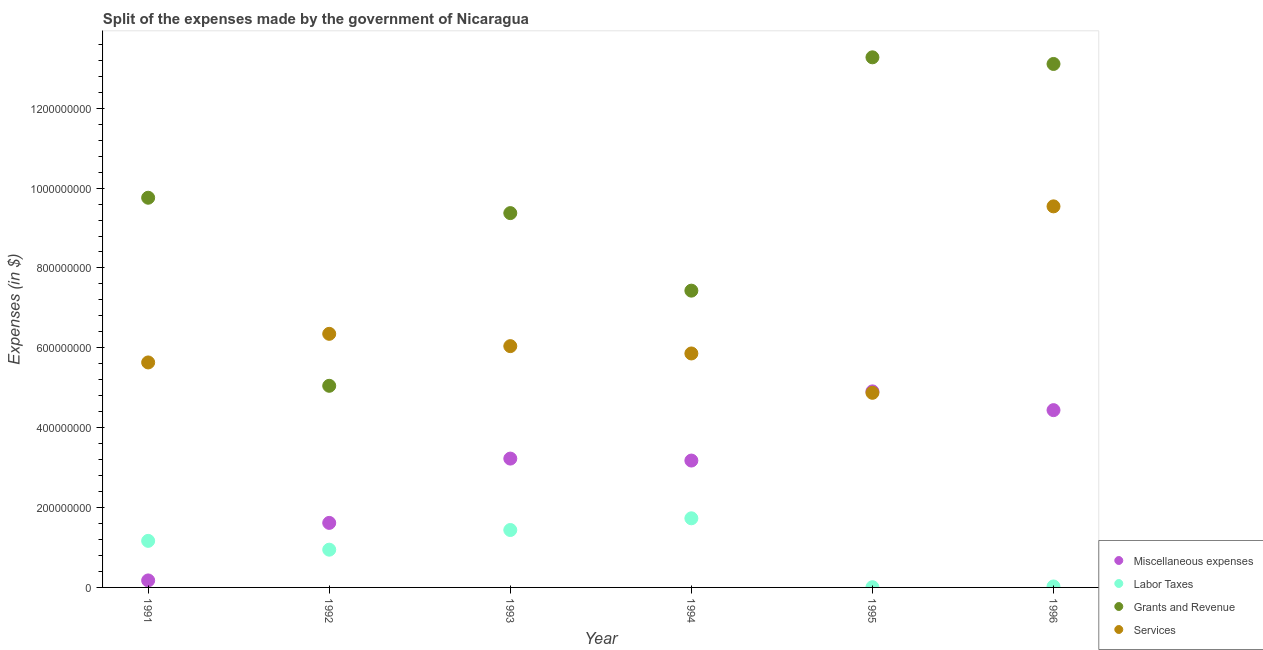How many different coloured dotlines are there?
Ensure brevity in your answer.  4. Is the number of dotlines equal to the number of legend labels?
Offer a very short reply. Yes. What is the amount spent on miscellaneous expenses in 1995?
Your answer should be very brief. 4.91e+08. Across all years, what is the maximum amount spent on grants and revenue?
Offer a very short reply. 1.33e+09. Across all years, what is the minimum amount spent on services?
Provide a succinct answer. 4.87e+08. What is the total amount spent on grants and revenue in the graph?
Offer a terse response. 5.80e+09. What is the difference between the amount spent on services in 1991 and that in 1994?
Give a very brief answer. -2.25e+07. What is the difference between the amount spent on labor taxes in 1993 and the amount spent on grants and revenue in 1996?
Give a very brief answer. -1.17e+09. What is the average amount spent on services per year?
Offer a terse response. 6.38e+08. In the year 1996, what is the difference between the amount spent on miscellaneous expenses and amount spent on labor taxes?
Keep it short and to the point. 4.42e+08. In how many years, is the amount spent on labor taxes greater than 800000000 $?
Your answer should be very brief. 0. What is the ratio of the amount spent on miscellaneous expenses in 1991 to that in 1994?
Your answer should be compact. 0.06. What is the difference between the highest and the second highest amount spent on services?
Ensure brevity in your answer.  3.19e+08. What is the difference between the highest and the lowest amount spent on services?
Your answer should be very brief. 4.67e+08. In how many years, is the amount spent on grants and revenue greater than the average amount spent on grants and revenue taken over all years?
Ensure brevity in your answer.  3. Is it the case that in every year, the sum of the amount spent on grants and revenue and amount spent on miscellaneous expenses is greater than the sum of amount spent on labor taxes and amount spent on services?
Make the answer very short. No. Is it the case that in every year, the sum of the amount spent on miscellaneous expenses and amount spent on labor taxes is greater than the amount spent on grants and revenue?
Keep it short and to the point. No. Does the amount spent on services monotonically increase over the years?
Offer a terse response. No. How many years are there in the graph?
Make the answer very short. 6. What is the difference between two consecutive major ticks on the Y-axis?
Provide a short and direct response. 2.00e+08. Are the values on the major ticks of Y-axis written in scientific E-notation?
Offer a very short reply. No. Does the graph contain any zero values?
Provide a short and direct response. No. Does the graph contain grids?
Offer a terse response. No. How many legend labels are there?
Keep it short and to the point. 4. How are the legend labels stacked?
Ensure brevity in your answer.  Vertical. What is the title of the graph?
Provide a short and direct response. Split of the expenses made by the government of Nicaragua. What is the label or title of the X-axis?
Provide a short and direct response. Year. What is the label or title of the Y-axis?
Offer a terse response. Expenses (in $). What is the Expenses (in $) in Miscellaneous expenses in 1991?
Ensure brevity in your answer.  1.75e+07. What is the Expenses (in $) of Labor Taxes in 1991?
Your response must be concise. 1.17e+08. What is the Expenses (in $) in Grants and Revenue in 1991?
Keep it short and to the point. 9.76e+08. What is the Expenses (in $) in Services in 1991?
Offer a terse response. 5.63e+08. What is the Expenses (in $) of Miscellaneous expenses in 1992?
Provide a short and direct response. 1.62e+08. What is the Expenses (in $) of Labor Taxes in 1992?
Give a very brief answer. 9.45e+07. What is the Expenses (in $) of Grants and Revenue in 1992?
Your answer should be very brief. 5.05e+08. What is the Expenses (in $) in Services in 1992?
Your response must be concise. 6.35e+08. What is the Expenses (in $) of Miscellaneous expenses in 1993?
Provide a short and direct response. 3.23e+08. What is the Expenses (in $) of Labor Taxes in 1993?
Ensure brevity in your answer.  1.44e+08. What is the Expenses (in $) in Grants and Revenue in 1993?
Offer a terse response. 9.37e+08. What is the Expenses (in $) of Services in 1993?
Ensure brevity in your answer.  6.04e+08. What is the Expenses (in $) in Miscellaneous expenses in 1994?
Make the answer very short. 3.18e+08. What is the Expenses (in $) of Labor Taxes in 1994?
Your answer should be compact. 1.73e+08. What is the Expenses (in $) in Grants and Revenue in 1994?
Provide a succinct answer. 7.43e+08. What is the Expenses (in $) in Services in 1994?
Give a very brief answer. 5.86e+08. What is the Expenses (in $) of Miscellaneous expenses in 1995?
Keep it short and to the point. 4.91e+08. What is the Expenses (in $) of Labor Taxes in 1995?
Offer a very short reply. 5.40e+05. What is the Expenses (in $) of Grants and Revenue in 1995?
Offer a terse response. 1.33e+09. What is the Expenses (in $) of Services in 1995?
Keep it short and to the point. 4.87e+08. What is the Expenses (in $) in Miscellaneous expenses in 1996?
Your response must be concise. 4.44e+08. What is the Expenses (in $) in Labor Taxes in 1996?
Provide a short and direct response. 2.40e+06. What is the Expenses (in $) of Grants and Revenue in 1996?
Offer a terse response. 1.31e+09. What is the Expenses (in $) in Services in 1996?
Your answer should be compact. 9.54e+08. Across all years, what is the maximum Expenses (in $) of Miscellaneous expenses?
Give a very brief answer. 4.91e+08. Across all years, what is the maximum Expenses (in $) of Labor Taxes?
Provide a short and direct response. 1.73e+08. Across all years, what is the maximum Expenses (in $) in Grants and Revenue?
Give a very brief answer. 1.33e+09. Across all years, what is the maximum Expenses (in $) in Services?
Ensure brevity in your answer.  9.54e+08. Across all years, what is the minimum Expenses (in $) in Miscellaneous expenses?
Ensure brevity in your answer.  1.75e+07. Across all years, what is the minimum Expenses (in $) in Labor Taxes?
Provide a succinct answer. 5.40e+05. Across all years, what is the minimum Expenses (in $) of Grants and Revenue?
Your answer should be very brief. 5.05e+08. Across all years, what is the minimum Expenses (in $) of Services?
Your answer should be very brief. 4.87e+08. What is the total Expenses (in $) in Miscellaneous expenses in the graph?
Ensure brevity in your answer.  1.75e+09. What is the total Expenses (in $) in Labor Taxes in the graph?
Offer a terse response. 5.31e+08. What is the total Expenses (in $) in Grants and Revenue in the graph?
Give a very brief answer. 5.80e+09. What is the total Expenses (in $) of Services in the graph?
Ensure brevity in your answer.  3.83e+09. What is the difference between the Expenses (in $) in Miscellaneous expenses in 1991 and that in 1992?
Provide a short and direct response. -1.44e+08. What is the difference between the Expenses (in $) of Labor Taxes in 1991 and that in 1992?
Keep it short and to the point. 2.20e+07. What is the difference between the Expenses (in $) in Grants and Revenue in 1991 and that in 1992?
Offer a terse response. 4.71e+08. What is the difference between the Expenses (in $) in Services in 1991 and that in 1992?
Offer a very short reply. -7.16e+07. What is the difference between the Expenses (in $) of Miscellaneous expenses in 1991 and that in 1993?
Offer a terse response. -3.05e+08. What is the difference between the Expenses (in $) in Labor Taxes in 1991 and that in 1993?
Your answer should be very brief. -2.72e+07. What is the difference between the Expenses (in $) in Grants and Revenue in 1991 and that in 1993?
Your response must be concise. 3.85e+07. What is the difference between the Expenses (in $) of Services in 1991 and that in 1993?
Your response must be concise. -4.08e+07. What is the difference between the Expenses (in $) in Miscellaneous expenses in 1991 and that in 1994?
Keep it short and to the point. -3.00e+08. What is the difference between the Expenses (in $) in Labor Taxes in 1991 and that in 1994?
Your answer should be compact. -5.65e+07. What is the difference between the Expenses (in $) in Grants and Revenue in 1991 and that in 1994?
Make the answer very short. 2.33e+08. What is the difference between the Expenses (in $) of Services in 1991 and that in 1994?
Make the answer very short. -2.25e+07. What is the difference between the Expenses (in $) in Miscellaneous expenses in 1991 and that in 1995?
Keep it short and to the point. -4.73e+08. What is the difference between the Expenses (in $) in Labor Taxes in 1991 and that in 1995?
Make the answer very short. 1.16e+08. What is the difference between the Expenses (in $) in Grants and Revenue in 1991 and that in 1995?
Your answer should be very brief. -3.52e+08. What is the difference between the Expenses (in $) of Services in 1991 and that in 1995?
Offer a terse response. 7.61e+07. What is the difference between the Expenses (in $) in Miscellaneous expenses in 1991 and that in 1996?
Your answer should be compact. -4.26e+08. What is the difference between the Expenses (in $) in Labor Taxes in 1991 and that in 1996?
Offer a very short reply. 1.14e+08. What is the difference between the Expenses (in $) of Grants and Revenue in 1991 and that in 1996?
Provide a succinct answer. -3.35e+08. What is the difference between the Expenses (in $) of Services in 1991 and that in 1996?
Offer a very short reply. -3.91e+08. What is the difference between the Expenses (in $) in Miscellaneous expenses in 1992 and that in 1993?
Offer a very short reply. -1.61e+08. What is the difference between the Expenses (in $) of Labor Taxes in 1992 and that in 1993?
Provide a succinct answer. -4.93e+07. What is the difference between the Expenses (in $) of Grants and Revenue in 1992 and that in 1993?
Ensure brevity in your answer.  -4.32e+08. What is the difference between the Expenses (in $) of Services in 1992 and that in 1993?
Make the answer very short. 3.08e+07. What is the difference between the Expenses (in $) in Miscellaneous expenses in 1992 and that in 1994?
Offer a terse response. -1.56e+08. What is the difference between the Expenses (in $) of Labor Taxes in 1992 and that in 1994?
Your answer should be compact. -7.86e+07. What is the difference between the Expenses (in $) in Grants and Revenue in 1992 and that in 1994?
Your answer should be compact. -2.38e+08. What is the difference between the Expenses (in $) in Services in 1992 and that in 1994?
Your answer should be compact. 4.92e+07. What is the difference between the Expenses (in $) in Miscellaneous expenses in 1992 and that in 1995?
Offer a very short reply. -3.29e+08. What is the difference between the Expenses (in $) in Labor Taxes in 1992 and that in 1995?
Give a very brief answer. 9.40e+07. What is the difference between the Expenses (in $) of Grants and Revenue in 1992 and that in 1995?
Provide a succinct answer. -8.23e+08. What is the difference between the Expenses (in $) in Services in 1992 and that in 1995?
Offer a very short reply. 1.48e+08. What is the difference between the Expenses (in $) in Miscellaneous expenses in 1992 and that in 1996?
Keep it short and to the point. -2.82e+08. What is the difference between the Expenses (in $) in Labor Taxes in 1992 and that in 1996?
Your answer should be very brief. 9.21e+07. What is the difference between the Expenses (in $) in Grants and Revenue in 1992 and that in 1996?
Your response must be concise. -8.06e+08. What is the difference between the Expenses (in $) in Services in 1992 and that in 1996?
Your response must be concise. -3.19e+08. What is the difference between the Expenses (in $) of Miscellaneous expenses in 1993 and that in 1994?
Offer a very short reply. 4.91e+06. What is the difference between the Expenses (in $) in Labor Taxes in 1993 and that in 1994?
Ensure brevity in your answer.  -2.93e+07. What is the difference between the Expenses (in $) of Grants and Revenue in 1993 and that in 1994?
Your answer should be compact. 1.94e+08. What is the difference between the Expenses (in $) in Services in 1993 and that in 1994?
Give a very brief answer. 1.84e+07. What is the difference between the Expenses (in $) of Miscellaneous expenses in 1993 and that in 1995?
Your response must be concise. -1.68e+08. What is the difference between the Expenses (in $) in Labor Taxes in 1993 and that in 1995?
Your answer should be very brief. 1.43e+08. What is the difference between the Expenses (in $) of Grants and Revenue in 1993 and that in 1995?
Your response must be concise. -3.90e+08. What is the difference between the Expenses (in $) of Services in 1993 and that in 1995?
Provide a succinct answer. 1.17e+08. What is the difference between the Expenses (in $) of Miscellaneous expenses in 1993 and that in 1996?
Offer a terse response. -1.21e+08. What is the difference between the Expenses (in $) in Labor Taxes in 1993 and that in 1996?
Ensure brevity in your answer.  1.41e+08. What is the difference between the Expenses (in $) in Grants and Revenue in 1993 and that in 1996?
Keep it short and to the point. -3.74e+08. What is the difference between the Expenses (in $) in Services in 1993 and that in 1996?
Keep it short and to the point. -3.50e+08. What is the difference between the Expenses (in $) in Miscellaneous expenses in 1994 and that in 1995?
Ensure brevity in your answer.  -1.73e+08. What is the difference between the Expenses (in $) of Labor Taxes in 1994 and that in 1995?
Provide a succinct answer. 1.73e+08. What is the difference between the Expenses (in $) of Grants and Revenue in 1994 and that in 1995?
Provide a short and direct response. -5.84e+08. What is the difference between the Expenses (in $) in Services in 1994 and that in 1995?
Make the answer very short. 9.85e+07. What is the difference between the Expenses (in $) in Miscellaneous expenses in 1994 and that in 1996?
Ensure brevity in your answer.  -1.26e+08. What is the difference between the Expenses (in $) in Labor Taxes in 1994 and that in 1996?
Your answer should be compact. 1.71e+08. What is the difference between the Expenses (in $) in Grants and Revenue in 1994 and that in 1996?
Keep it short and to the point. -5.68e+08. What is the difference between the Expenses (in $) in Services in 1994 and that in 1996?
Your answer should be compact. -3.68e+08. What is the difference between the Expenses (in $) in Miscellaneous expenses in 1995 and that in 1996?
Ensure brevity in your answer.  4.70e+07. What is the difference between the Expenses (in $) in Labor Taxes in 1995 and that in 1996?
Provide a succinct answer. -1.86e+06. What is the difference between the Expenses (in $) of Grants and Revenue in 1995 and that in 1996?
Make the answer very short. 1.66e+07. What is the difference between the Expenses (in $) of Services in 1995 and that in 1996?
Give a very brief answer. -4.67e+08. What is the difference between the Expenses (in $) of Miscellaneous expenses in 1991 and the Expenses (in $) of Labor Taxes in 1992?
Offer a terse response. -7.70e+07. What is the difference between the Expenses (in $) of Miscellaneous expenses in 1991 and the Expenses (in $) of Grants and Revenue in 1992?
Make the answer very short. -4.87e+08. What is the difference between the Expenses (in $) in Miscellaneous expenses in 1991 and the Expenses (in $) in Services in 1992?
Give a very brief answer. -6.18e+08. What is the difference between the Expenses (in $) in Labor Taxes in 1991 and the Expenses (in $) in Grants and Revenue in 1992?
Provide a succinct answer. -3.88e+08. What is the difference between the Expenses (in $) of Labor Taxes in 1991 and the Expenses (in $) of Services in 1992?
Make the answer very short. -5.18e+08. What is the difference between the Expenses (in $) in Grants and Revenue in 1991 and the Expenses (in $) in Services in 1992?
Keep it short and to the point. 3.41e+08. What is the difference between the Expenses (in $) of Miscellaneous expenses in 1991 and the Expenses (in $) of Labor Taxes in 1993?
Offer a very short reply. -1.26e+08. What is the difference between the Expenses (in $) in Miscellaneous expenses in 1991 and the Expenses (in $) in Grants and Revenue in 1993?
Provide a short and direct response. -9.20e+08. What is the difference between the Expenses (in $) in Miscellaneous expenses in 1991 and the Expenses (in $) in Services in 1993?
Offer a terse response. -5.87e+08. What is the difference between the Expenses (in $) in Labor Taxes in 1991 and the Expenses (in $) in Grants and Revenue in 1993?
Provide a succinct answer. -8.21e+08. What is the difference between the Expenses (in $) of Labor Taxes in 1991 and the Expenses (in $) of Services in 1993?
Ensure brevity in your answer.  -4.88e+08. What is the difference between the Expenses (in $) in Grants and Revenue in 1991 and the Expenses (in $) in Services in 1993?
Offer a terse response. 3.72e+08. What is the difference between the Expenses (in $) of Miscellaneous expenses in 1991 and the Expenses (in $) of Labor Taxes in 1994?
Your answer should be very brief. -1.56e+08. What is the difference between the Expenses (in $) in Miscellaneous expenses in 1991 and the Expenses (in $) in Grants and Revenue in 1994?
Offer a terse response. -7.26e+08. What is the difference between the Expenses (in $) of Miscellaneous expenses in 1991 and the Expenses (in $) of Services in 1994?
Keep it short and to the point. -5.68e+08. What is the difference between the Expenses (in $) in Labor Taxes in 1991 and the Expenses (in $) in Grants and Revenue in 1994?
Your answer should be compact. -6.27e+08. What is the difference between the Expenses (in $) in Labor Taxes in 1991 and the Expenses (in $) in Services in 1994?
Provide a succinct answer. -4.69e+08. What is the difference between the Expenses (in $) in Grants and Revenue in 1991 and the Expenses (in $) in Services in 1994?
Your answer should be very brief. 3.90e+08. What is the difference between the Expenses (in $) in Miscellaneous expenses in 1991 and the Expenses (in $) in Labor Taxes in 1995?
Give a very brief answer. 1.70e+07. What is the difference between the Expenses (in $) in Miscellaneous expenses in 1991 and the Expenses (in $) in Grants and Revenue in 1995?
Ensure brevity in your answer.  -1.31e+09. What is the difference between the Expenses (in $) of Miscellaneous expenses in 1991 and the Expenses (in $) of Services in 1995?
Provide a succinct answer. -4.70e+08. What is the difference between the Expenses (in $) of Labor Taxes in 1991 and the Expenses (in $) of Grants and Revenue in 1995?
Provide a succinct answer. -1.21e+09. What is the difference between the Expenses (in $) of Labor Taxes in 1991 and the Expenses (in $) of Services in 1995?
Give a very brief answer. -3.71e+08. What is the difference between the Expenses (in $) in Grants and Revenue in 1991 and the Expenses (in $) in Services in 1995?
Offer a terse response. 4.89e+08. What is the difference between the Expenses (in $) of Miscellaneous expenses in 1991 and the Expenses (in $) of Labor Taxes in 1996?
Your answer should be very brief. 1.51e+07. What is the difference between the Expenses (in $) of Miscellaneous expenses in 1991 and the Expenses (in $) of Grants and Revenue in 1996?
Provide a succinct answer. -1.29e+09. What is the difference between the Expenses (in $) in Miscellaneous expenses in 1991 and the Expenses (in $) in Services in 1996?
Provide a succinct answer. -9.37e+08. What is the difference between the Expenses (in $) of Labor Taxes in 1991 and the Expenses (in $) of Grants and Revenue in 1996?
Ensure brevity in your answer.  -1.19e+09. What is the difference between the Expenses (in $) of Labor Taxes in 1991 and the Expenses (in $) of Services in 1996?
Provide a succinct answer. -8.38e+08. What is the difference between the Expenses (in $) of Grants and Revenue in 1991 and the Expenses (in $) of Services in 1996?
Keep it short and to the point. 2.16e+07. What is the difference between the Expenses (in $) of Miscellaneous expenses in 1992 and the Expenses (in $) of Labor Taxes in 1993?
Your answer should be compact. 1.78e+07. What is the difference between the Expenses (in $) in Miscellaneous expenses in 1992 and the Expenses (in $) in Grants and Revenue in 1993?
Give a very brief answer. -7.76e+08. What is the difference between the Expenses (in $) of Miscellaneous expenses in 1992 and the Expenses (in $) of Services in 1993?
Make the answer very short. -4.43e+08. What is the difference between the Expenses (in $) of Labor Taxes in 1992 and the Expenses (in $) of Grants and Revenue in 1993?
Make the answer very short. -8.43e+08. What is the difference between the Expenses (in $) in Labor Taxes in 1992 and the Expenses (in $) in Services in 1993?
Provide a short and direct response. -5.10e+08. What is the difference between the Expenses (in $) in Grants and Revenue in 1992 and the Expenses (in $) in Services in 1993?
Make the answer very short. -9.93e+07. What is the difference between the Expenses (in $) of Miscellaneous expenses in 1992 and the Expenses (in $) of Labor Taxes in 1994?
Ensure brevity in your answer.  -1.15e+07. What is the difference between the Expenses (in $) of Miscellaneous expenses in 1992 and the Expenses (in $) of Grants and Revenue in 1994?
Provide a short and direct response. -5.82e+08. What is the difference between the Expenses (in $) of Miscellaneous expenses in 1992 and the Expenses (in $) of Services in 1994?
Your answer should be compact. -4.24e+08. What is the difference between the Expenses (in $) in Labor Taxes in 1992 and the Expenses (in $) in Grants and Revenue in 1994?
Offer a terse response. -6.49e+08. What is the difference between the Expenses (in $) of Labor Taxes in 1992 and the Expenses (in $) of Services in 1994?
Make the answer very short. -4.91e+08. What is the difference between the Expenses (in $) of Grants and Revenue in 1992 and the Expenses (in $) of Services in 1994?
Your answer should be very brief. -8.10e+07. What is the difference between the Expenses (in $) of Miscellaneous expenses in 1992 and the Expenses (in $) of Labor Taxes in 1995?
Provide a succinct answer. 1.61e+08. What is the difference between the Expenses (in $) of Miscellaneous expenses in 1992 and the Expenses (in $) of Grants and Revenue in 1995?
Make the answer very short. -1.17e+09. What is the difference between the Expenses (in $) in Miscellaneous expenses in 1992 and the Expenses (in $) in Services in 1995?
Offer a very short reply. -3.26e+08. What is the difference between the Expenses (in $) in Labor Taxes in 1992 and the Expenses (in $) in Grants and Revenue in 1995?
Provide a short and direct response. -1.23e+09. What is the difference between the Expenses (in $) of Labor Taxes in 1992 and the Expenses (in $) of Services in 1995?
Give a very brief answer. -3.93e+08. What is the difference between the Expenses (in $) in Grants and Revenue in 1992 and the Expenses (in $) in Services in 1995?
Your answer should be compact. 1.76e+07. What is the difference between the Expenses (in $) of Miscellaneous expenses in 1992 and the Expenses (in $) of Labor Taxes in 1996?
Ensure brevity in your answer.  1.59e+08. What is the difference between the Expenses (in $) in Miscellaneous expenses in 1992 and the Expenses (in $) in Grants and Revenue in 1996?
Keep it short and to the point. -1.15e+09. What is the difference between the Expenses (in $) of Miscellaneous expenses in 1992 and the Expenses (in $) of Services in 1996?
Ensure brevity in your answer.  -7.93e+08. What is the difference between the Expenses (in $) in Labor Taxes in 1992 and the Expenses (in $) in Grants and Revenue in 1996?
Your answer should be very brief. -1.22e+09. What is the difference between the Expenses (in $) of Labor Taxes in 1992 and the Expenses (in $) of Services in 1996?
Provide a short and direct response. -8.60e+08. What is the difference between the Expenses (in $) in Grants and Revenue in 1992 and the Expenses (in $) in Services in 1996?
Ensure brevity in your answer.  -4.49e+08. What is the difference between the Expenses (in $) in Miscellaneous expenses in 1993 and the Expenses (in $) in Labor Taxes in 1994?
Ensure brevity in your answer.  1.50e+08. What is the difference between the Expenses (in $) of Miscellaneous expenses in 1993 and the Expenses (in $) of Grants and Revenue in 1994?
Provide a short and direct response. -4.21e+08. What is the difference between the Expenses (in $) in Miscellaneous expenses in 1993 and the Expenses (in $) in Services in 1994?
Your answer should be compact. -2.63e+08. What is the difference between the Expenses (in $) of Labor Taxes in 1993 and the Expenses (in $) of Grants and Revenue in 1994?
Give a very brief answer. -5.99e+08. What is the difference between the Expenses (in $) of Labor Taxes in 1993 and the Expenses (in $) of Services in 1994?
Make the answer very short. -4.42e+08. What is the difference between the Expenses (in $) of Grants and Revenue in 1993 and the Expenses (in $) of Services in 1994?
Provide a succinct answer. 3.51e+08. What is the difference between the Expenses (in $) in Miscellaneous expenses in 1993 and the Expenses (in $) in Labor Taxes in 1995?
Your response must be concise. 3.22e+08. What is the difference between the Expenses (in $) of Miscellaneous expenses in 1993 and the Expenses (in $) of Grants and Revenue in 1995?
Give a very brief answer. -1.00e+09. What is the difference between the Expenses (in $) in Miscellaneous expenses in 1993 and the Expenses (in $) in Services in 1995?
Offer a very short reply. -1.65e+08. What is the difference between the Expenses (in $) in Labor Taxes in 1993 and the Expenses (in $) in Grants and Revenue in 1995?
Offer a very short reply. -1.18e+09. What is the difference between the Expenses (in $) in Labor Taxes in 1993 and the Expenses (in $) in Services in 1995?
Your response must be concise. -3.44e+08. What is the difference between the Expenses (in $) in Grants and Revenue in 1993 and the Expenses (in $) in Services in 1995?
Offer a terse response. 4.50e+08. What is the difference between the Expenses (in $) in Miscellaneous expenses in 1993 and the Expenses (in $) in Labor Taxes in 1996?
Provide a short and direct response. 3.20e+08. What is the difference between the Expenses (in $) in Miscellaneous expenses in 1993 and the Expenses (in $) in Grants and Revenue in 1996?
Your response must be concise. -9.88e+08. What is the difference between the Expenses (in $) of Miscellaneous expenses in 1993 and the Expenses (in $) of Services in 1996?
Your answer should be very brief. -6.32e+08. What is the difference between the Expenses (in $) in Labor Taxes in 1993 and the Expenses (in $) in Grants and Revenue in 1996?
Offer a very short reply. -1.17e+09. What is the difference between the Expenses (in $) of Labor Taxes in 1993 and the Expenses (in $) of Services in 1996?
Your answer should be very brief. -8.10e+08. What is the difference between the Expenses (in $) in Grants and Revenue in 1993 and the Expenses (in $) in Services in 1996?
Your answer should be compact. -1.69e+07. What is the difference between the Expenses (in $) in Miscellaneous expenses in 1994 and the Expenses (in $) in Labor Taxes in 1995?
Your answer should be compact. 3.17e+08. What is the difference between the Expenses (in $) in Miscellaneous expenses in 1994 and the Expenses (in $) in Grants and Revenue in 1995?
Offer a very short reply. -1.01e+09. What is the difference between the Expenses (in $) in Miscellaneous expenses in 1994 and the Expenses (in $) in Services in 1995?
Your answer should be very brief. -1.70e+08. What is the difference between the Expenses (in $) of Labor Taxes in 1994 and the Expenses (in $) of Grants and Revenue in 1995?
Give a very brief answer. -1.15e+09. What is the difference between the Expenses (in $) in Labor Taxes in 1994 and the Expenses (in $) in Services in 1995?
Offer a terse response. -3.14e+08. What is the difference between the Expenses (in $) in Grants and Revenue in 1994 and the Expenses (in $) in Services in 1995?
Keep it short and to the point. 2.56e+08. What is the difference between the Expenses (in $) in Miscellaneous expenses in 1994 and the Expenses (in $) in Labor Taxes in 1996?
Keep it short and to the point. 3.15e+08. What is the difference between the Expenses (in $) in Miscellaneous expenses in 1994 and the Expenses (in $) in Grants and Revenue in 1996?
Offer a terse response. -9.93e+08. What is the difference between the Expenses (in $) in Miscellaneous expenses in 1994 and the Expenses (in $) in Services in 1996?
Your answer should be very brief. -6.37e+08. What is the difference between the Expenses (in $) in Labor Taxes in 1994 and the Expenses (in $) in Grants and Revenue in 1996?
Your answer should be compact. -1.14e+09. What is the difference between the Expenses (in $) in Labor Taxes in 1994 and the Expenses (in $) in Services in 1996?
Give a very brief answer. -7.81e+08. What is the difference between the Expenses (in $) in Grants and Revenue in 1994 and the Expenses (in $) in Services in 1996?
Your response must be concise. -2.11e+08. What is the difference between the Expenses (in $) in Miscellaneous expenses in 1995 and the Expenses (in $) in Labor Taxes in 1996?
Give a very brief answer. 4.89e+08. What is the difference between the Expenses (in $) of Miscellaneous expenses in 1995 and the Expenses (in $) of Grants and Revenue in 1996?
Your response must be concise. -8.20e+08. What is the difference between the Expenses (in $) in Miscellaneous expenses in 1995 and the Expenses (in $) in Services in 1996?
Keep it short and to the point. -4.63e+08. What is the difference between the Expenses (in $) in Labor Taxes in 1995 and the Expenses (in $) in Grants and Revenue in 1996?
Your answer should be compact. -1.31e+09. What is the difference between the Expenses (in $) of Labor Taxes in 1995 and the Expenses (in $) of Services in 1996?
Make the answer very short. -9.54e+08. What is the difference between the Expenses (in $) of Grants and Revenue in 1995 and the Expenses (in $) of Services in 1996?
Offer a terse response. 3.73e+08. What is the average Expenses (in $) in Miscellaneous expenses per year?
Give a very brief answer. 2.92e+08. What is the average Expenses (in $) in Labor Taxes per year?
Keep it short and to the point. 8.85e+07. What is the average Expenses (in $) in Grants and Revenue per year?
Keep it short and to the point. 9.67e+08. What is the average Expenses (in $) of Services per year?
Provide a short and direct response. 6.38e+08. In the year 1991, what is the difference between the Expenses (in $) of Miscellaneous expenses and Expenses (in $) of Labor Taxes?
Provide a short and direct response. -9.91e+07. In the year 1991, what is the difference between the Expenses (in $) of Miscellaneous expenses and Expenses (in $) of Grants and Revenue?
Your answer should be very brief. -9.58e+08. In the year 1991, what is the difference between the Expenses (in $) of Miscellaneous expenses and Expenses (in $) of Services?
Offer a terse response. -5.46e+08. In the year 1991, what is the difference between the Expenses (in $) in Labor Taxes and Expenses (in $) in Grants and Revenue?
Provide a short and direct response. -8.59e+08. In the year 1991, what is the difference between the Expenses (in $) of Labor Taxes and Expenses (in $) of Services?
Offer a very short reply. -4.47e+08. In the year 1991, what is the difference between the Expenses (in $) in Grants and Revenue and Expenses (in $) in Services?
Give a very brief answer. 4.12e+08. In the year 1992, what is the difference between the Expenses (in $) of Miscellaneous expenses and Expenses (in $) of Labor Taxes?
Provide a succinct answer. 6.71e+07. In the year 1992, what is the difference between the Expenses (in $) of Miscellaneous expenses and Expenses (in $) of Grants and Revenue?
Give a very brief answer. -3.43e+08. In the year 1992, what is the difference between the Expenses (in $) of Miscellaneous expenses and Expenses (in $) of Services?
Give a very brief answer. -4.73e+08. In the year 1992, what is the difference between the Expenses (in $) of Labor Taxes and Expenses (in $) of Grants and Revenue?
Your answer should be compact. -4.10e+08. In the year 1992, what is the difference between the Expenses (in $) in Labor Taxes and Expenses (in $) in Services?
Your response must be concise. -5.41e+08. In the year 1992, what is the difference between the Expenses (in $) in Grants and Revenue and Expenses (in $) in Services?
Your response must be concise. -1.30e+08. In the year 1993, what is the difference between the Expenses (in $) of Miscellaneous expenses and Expenses (in $) of Labor Taxes?
Your answer should be compact. 1.79e+08. In the year 1993, what is the difference between the Expenses (in $) in Miscellaneous expenses and Expenses (in $) in Grants and Revenue?
Provide a succinct answer. -6.15e+08. In the year 1993, what is the difference between the Expenses (in $) of Miscellaneous expenses and Expenses (in $) of Services?
Your answer should be compact. -2.82e+08. In the year 1993, what is the difference between the Expenses (in $) in Labor Taxes and Expenses (in $) in Grants and Revenue?
Ensure brevity in your answer.  -7.94e+08. In the year 1993, what is the difference between the Expenses (in $) in Labor Taxes and Expenses (in $) in Services?
Your response must be concise. -4.60e+08. In the year 1993, what is the difference between the Expenses (in $) in Grants and Revenue and Expenses (in $) in Services?
Make the answer very short. 3.33e+08. In the year 1994, what is the difference between the Expenses (in $) in Miscellaneous expenses and Expenses (in $) in Labor Taxes?
Offer a very short reply. 1.45e+08. In the year 1994, what is the difference between the Expenses (in $) in Miscellaneous expenses and Expenses (in $) in Grants and Revenue?
Give a very brief answer. -4.25e+08. In the year 1994, what is the difference between the Expenses (in $) of Miscellaneous expenses and Expenses (in $) of Services?
Your answer should be compact. -2.68e+08. In the year 1994, what is the difference between the Expenses (in $) in Labor Taxes and Expenses (in $) in Grants and Revenue?
Ensure brevity in your answer.  -5.70e+08. In the year 1994, what is the difference between the Expenses (in $) of Labor Taxes and Expenses (in $) of Services?
Offer a very short reply. -4.13e+08. In the year 1994, what is the difference between the Expenses (in $) in Grants and Revenue and Expenses (in $) in Services?
Your response must be concise. 1.57e+08. In the year 1995, what is the difference between the Expenses (in $) of Miscellaneous expenses and Expenses (in $) of Labor Taxes?
Provide a succinct answer. 4.90e+08. In the year 1995, what is the difference between the Expenses (in $) of Miscellaneous expenses and Expenses (in $) of Grants and Revenue?
Make the answer very short. -8.37e+08. In the year 1995, what is the difference between the Expenses (in $) in Miscellaneous expenses and Expenses (in $) in Services?
Your answer should be very brief. 3.57e+06. In the year 1995, what is the difference between the Expenses (in $) in Labor Taxes and Expenses (in $) in Grants and Revenue?
Provide a succinct answer. -1.33e+09. In the year 1995, what is the difference between the Expenses (in $) in Labor Taxes and Expenses (in $) in Services?
Ensure brevity in your answer.  -4.87e+08. In the year 1995, what is the difference between the Expenses (in $) of Grants and Revenue and Expenses (in $) of Services?
Your answer should be very brief. 8.40e+08. In the year 1996, what is the difference between the Expenses (in $) in Miscellaneous expenses and Expenses (in $) in Labor Taxes?
Ensure brevity in your answer.  4.42e+08. In the year 1996, what is the difference between the Expenses (in $) in Miscellaneous expenses and Expenses (in $) in Grants and Revenue?
Provide a succinct answer. -8.67e+08. In the year 1996, what is the difference between the Expenses (in $) of Miscellaneous expenses and Expenses (in $) of Services?
Make the answer very short. -5.10e+08. In the year 1996, what is the difference between the Expenses (in $) in Labor Taxes and Expenses (in $) in Grants and Revenue?
Provide a succinct answer. -1.31e+09. In the year 1996, what is the difference between the Expenses (in $) of Labor Taxes and Expenses (in $) of Services?
Make the answer very short. -9.52e+08. In the year 1996, what is the difference between the Expenses (in $) of Grants and Revenue and Expenses (in $) of Services?
Provide a short and direct response. 3.57e+08. What is the ratio of the Expenses (in $) in Miscellaneous expenses in 1991 to that in 1992?
Offer a terse response. 0.11. What is the ratio of the Expenses (in $) of Labor Taxes in 1991 to that in 1992?
Your answer should be very brief. 1.23. What is the ratio of the Expenses (in $) in Grants and Revenue in 1991 to that in 1992?
Provide a short and direct response. 1.93. What is the ratio of the Expenses (in $) of Services in 1991 to that in 1992?
Your response must be concise. 0.89. What is the ratio of the Expenses (in $) in Miscellaneous expenses in 1991 to that in 1993?
Your answer should be very brief. 0.05. What is the ratio of the Expenses (in $) of Labor Taxes in 1991 to that in 1993?
Ensure brevity in your answer.  0.81. What is the ratio of the Expenses (in $) of Grants and Revenue in 1991 to that in 1993?
Keep it short and to the point. 1.04. What is the ratio of the Expenses (in $) in Services in 1991 to that in 1993?
Your response must be concise. 0.93. What is the ratio of the Expenses (in $) in Miscellaneous expenses in 1991 to that in 1994?
Your answer should be very brief. 0.06. What is the ratio of the Expenses (in $) of Labor Taxes in 1991 to that in 1994?
Ensure brevity in your answer.  0.67. What is the ratio of the Expenses (in $) in Grants and Revenue in 1991 to that in 1994?
Keep it short and to the point. 1.31. What is the ratio of the Expenses (in $) of Services in 1991 to that in 1994?
Your answer should be compact. 0.96. What is the ratio of the Expenses (in $) in Miscellaneous expenses in 1991 to that in 1995?
Offer a very short reply. 0.04. What is the ratio of the Expenses (in $) in Labor Taxes in 1991 to that in 1995?
Your answer should be compact. 215.91. What is the ratio of the Expenses (in $) of Grants and Revenue in 1991 to that in 1995?
Provide a short and direct response. 0.74. What is the ratio of the Expenses (in $) in Services in 1991 to that in 1995?
Your answer should be compact. 1.16. What is the ratio of the Expenses (in $) of Miscellaneous expenses in 1991 to that in 1996?
Your response must be concise. 0.04. What is the ratio of the Expenses (in $) of Labor Taxes in 1991 to that in 1996?
Offer a very short reply. 48.58. What is the ratio of the Expenses (in $) in Grants and Revenue in 1991 to that in 1996?
Give a very brief answer. 0.74. What is the ratio of the Expenses (in $) of Services in 1991 to that in 1996?
Keep it short and to the point. 0.59. What is the ratio of the Expenses (in $) in Miscellaneous expenses in 1992 to that in 1993?
Provide a short and direct response. 0.5. What is the ratio of the Expenses (in $) of Labor Taxes in 1992 to that in 1993?
Keep it short and to the point. 0.66. What is the ratio of the Expenses (in $) of Grants and Revenue in 1992 to that in 1993?
Give a very brief answer. 0.54. What is the ratio of the Expenses (in $) of Services in 1992 to that in 1993?
Your response must be concise. 1.05. What is the ratio of the Expenses (in $) in Miscellaneous expenses in 1992 to that in 1994?
Offer a terse response. 0.51. What is the ratio of the Expenses (in $) in Labor Taxes in 1992 to that in 1994?
Keep it short and to the point. 0.55. What is the ratio of the Expenses (in $) of Grants and Revenue in 1992 to that in 1994?
Ensure brevity in your answer.  0.68. What is the ratio of the Expenses (in $) in Services in 1992 to that in 1994?
Make the answer very short. 1.08. What is the ratio of the Expenses (in $) in Miscellaneous expenses in 1992 to that in 1995?
Provide a succinct answer. 0.33. What is the ratio of the Expenses (in $) in Labor Taxes in 1992 to that in 1995?
Ensure brevity in your answer.  175.07. What is the ratio of the Expenses (in $) of Grants and Revenue in 1992 to that in 1995?
Provide a succinct answer. 0.38. What is the ratio of the Expenses (in $) in Services in 1992 to that in 1995?
Ensure brevity in your answer.  1.3. What is the ratio of the Expenses (in $) of Miscellaneous expenses in 1992 to that in 1996?
Ensure brevity in your answer.  0.36. What is the ratio of the Expenses (in $) of Labor Taxes in 1992 to that in 1996?
Your answer should be very brief. 39.39. What is the ratio of the Expenses (in $) of Grants and Revenue in 1992 to that in 1996?
Your answer should be compact. 0.39. What is the ratio of the Expenses (in $) in Services in 1992 to that in 1996?
Your response must be concise. 0.67. What is the ratio of the Expenses (in $) of Miscellaneous expenses in 1993 to that in 1994?
Provide a succinct answer. 1.02. What is the ratio of the Expenses (in $) of Labor Taxes in 1993 to that in 1994?
Offer a terse response. 0.83. What is the ratio of the Expenses (in $) of Grants and Revenue in 1993 to that in 1994?
Your answer should be compact. 1.26. What is the ratio of the Expenses (in $) in Services in 1993 to that in 1994?
Your response must be concise. 1.03. What is the ratio of the Expenses (in $) of Miscellaneous expenses in 1993 to that in 1995?
Your answer should be very brief. 0.66. What is the ratio of the Expenses (in $) of Labor Taxes in 1993 to that in 1995?
Keep it short and to the point. 266.3. What is the ratio of the Expenses (in $) in Grants and Revenue in 1993 to that in 1995?
Offer a very short reply. 0.71. What is the ratio of the Expenses (in $) in Services in 1993 to that in 1995?
Your response must be concise. 1.24. What is the ratio of the Expenses (in $) of Miscellaneous expenses in 1993 to that in 1996?
Give a very brief answer. 0.73. What is the ratio of the Expenses (in $) of Labor Taxes in 1993 to that in 1996?
Provide a short and direct response. 59.92. What is the ratio of the Expenses (in $) in Grants and Revenue in 1993 to that in 1996?
Offer a very short reply. 0.72. What is the ratio of the Expenses (in $) in Services in 1993 to that in 1996?
Your answer should be very brief. 0.63. What is the ratio of the Expenses (in $) in Miscellaneous expenses in 1994 to that in 1995?
Offer a very short reply. 0.65. What is the ratio of the Expenses (in $) of Labor Taxes in 1994 to that in 1995?
Provide a succinct answer. 320.54. What is the ratio of the Expenses (in $) of Grants and Revenue in 1994 to that in 1995?
Your response must be concise. 0.56. What is the ratio of the Expenses (in $) in Services in 1994 to that in 1995?
Your answer should be very brief. 1.2. What is the ratio of the Expenses (in $) of Miscellaneous expenses in 1994 to that in 1996?
Provide a short and direct response. 0.72. What is the ratio of the Expenses (in $) in Labor Taxes in 1994 to that in 1996?
Ensure brevity in your answer.  72.12. What is the ratio of the Expenses (in $) of Grants and Revenue in 1994 to that in 1996?
Offer a very short reply. 0.57. What is the ratio of the Expenses (in $) in Services in 1994 to that in 1996?
Ensure brevity in your answer.  0.61. What is the ratio of the Expenses (in $) in Miscellaneous expenses in 1995 to that in 1996?
Provide a short and direct response. 1.11. What is the ratio of the Expenses (in $) in Labor Taxes in 1995 to that in 1996?
Provide a short and direct response. 0.23. What is the ratio of the Expenses (in $) of Grants and Revenue in 1995 to that in 1996?
Make the answer very short. 1.01. What is the ratio of the Expenses (in $) in Services in 1995 to that in 1996?
Provide a succinct answer. 0.51. What is the difference between the highest and the second highest Expenses (in $) in Miscellaneous expenses?
Ensure brevity in your answer.  4.70e+07. What is the difference between the highest and the second highest Expenses (in $) in Labor Taxes?
Provide a short and direct response. 2.93e+07. What is the difference between the highest and the second highest Expenses (in $) in Grants and Revenue?
Provide a succinct answer. 1.66e+07. What is the difference between the highest and the second highest Expenses (in $) in Services?
Make the answer very short. 3.19e+08. What is the difference between the highest and the lowest Expenses (in $) of Miscellaneous expenses?
Your answer should be compact. 4.73e+08. What is the difference between the highest and the lowest Expenses (in $) in Labor Taxes?
Provide a short and direct response. 1.73e+08. What is the difference between the highest and the lowest Expenses (in $) in Grants and Revenue?
Give a very brief answer. 8.23e+08. What is the difference between the highest and the lowest Expenses (in $) in Services?
Your answer should be very brief. 4.67e+08. 